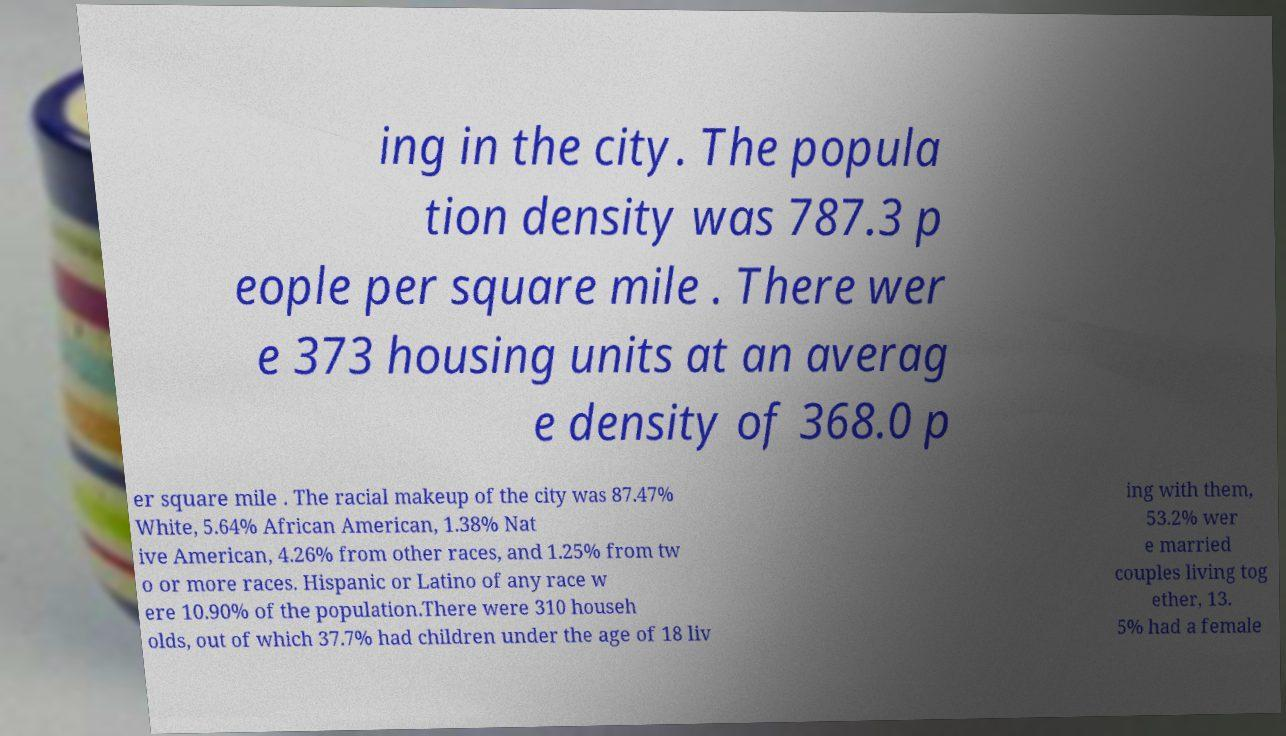Could you extract and type out the text from this image? ing in the city. The popula tion density was 787.3 p eople per square mile . There wer e 373 housing units at an averag e density of 368.0 p er square mile . The racial makeup of the city was 87.47% White, 5.64% African American, 1.38% Nat ive American, 4.26% from other races, and 1.25% from tw o or more races. Hispanic or Latino of any race w ere 10.90% of the population.There were 310 househ olds, out of which 37.7% had children under the age of 18 liv ing with them, 53.2% wer e married couples living tog ether, 13. 5% had a female 